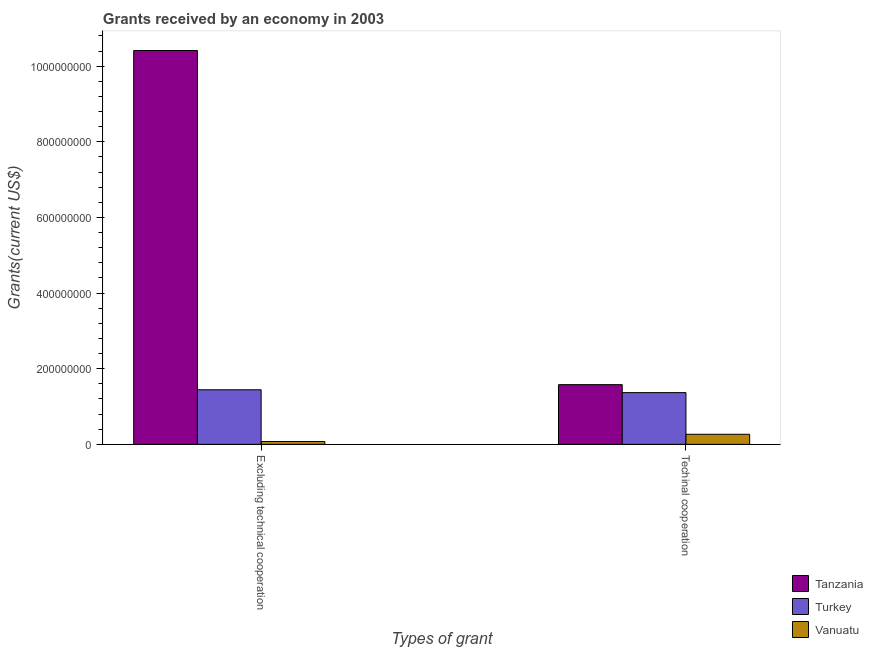Are the number of bars on each tick of the X-axis equal?
Make the answer very short. Yes. How many bars are there on the 2nd tick from the left?
Offer a terse response. 3. How many bars are there on the 1st tick from the right?
Your answer should be very brief. 3. What is the label of the 2nd group of bars from the left?
Offer a very short reply. Techinal cooperation. What is the amount of grants received(including technical cooperation) in Turkey?
Make the answer very short. 1.37e+08. Across all countries, what is the maximum amount of grants received(including technical cooperation)?
Your answer should be very brief. 1.58e+08. Across all countries, what is the minimum amount of grants received(excluding technical cooperation)?
Your response must be concise. 7.47e+06. In which country was the amount of grants received(excluding technical cooperation) maximum?
Your answer should be very brief. Tanzania. In which country was the amount of grants received(excluding technical cooperation) minimum?
Offer a terse response. Vanuatu. What is the total amount of grants received(including technical cooperation) in the graph?
Give a very brief answer. 3.21e+08. What is the difference between the amount of grants received(including technical cooperation) in Tanzania and that in Vanuatu?
Keep it short and to the point. 1.31e+08. What is the difference between the amount of grants received(excluding technical cooperation) in Turkey and the amount of grants received(including technical cooperation) in Vanuatu?
Your answer should be compact. 1.18e+08. What is the average amount of grants received(excluding technical cooperation) per country?
Your answer should be compact. 3.98e+08. What is the difference between the amount of grants received(including technical cooperation) and amount of grants received(excluding technical cooperation) in Turkey?
Your answer should be very brief. -7.53e+06. What is the ratio of the amount of grants received(excluding technical cooperation) in Vanuatu to that in Tanzania?
Ensure brevity in your answer.  0.01. Is the amount of grants received(excluding technical cooperation) in Vanuatu less than that in Turkey?
Keep it short and to the point. Yes. What does the 2nd bar from the left in Techinal cooperation represents?
Ensure brevity in your answer.  Turkey. What does the 1st bar from the right in Excluding technical cooperation represents?
Provide a succinct answer. Vanuatu. Are all the bars in the graph horizontal?
Your response must be concise. No. Does the graph contain grids?
Give a very brief answer. No. Where does the legend appear in the graph?
Offer a terse response. Bottom right. How many legend labels are there?
Make the answer very short. 3. How are the legend labels stacked?
Keep it short and to the point. Vertical. What is the title of the graph?
Your response must be concise. Grants received by an economy in 2003. Does "Qatar" appear as one of the legend labels in the graph?
Ensure brevity in your answer.  No. What is the label or title of the X-axis?
Give a very brief answer. Types of grant. What is the label or title of the Y-axis?
Provide a short and direct response. Grants(current US$). What is the Grants(current US$) of Tanzania in Excluding technical cooperation?
Give a very brief answer. 1.04e+09. What is the Grants(current US$) in Turkey in Excluding technical cooperation?
Make the answer very short. 1.44e+08. What is the Grants(current US$) in Vanuatu in Excluding technical cooperation?
Your answer should be very brief. 7.47e+06. What is the Grants(current US$) of Tanzania in Techinal cooperation?
Your answer should be very brief. 1.58e+08. What is the Grants(current US$) of Turkey in Techinal cooperation?
Offer a terse response. 1.37e+08. What is the Grants(current US$) of Vanuatu in Techinal cooperation?
Provide a succinct answer. 2.67e+07. Across all Types of grant, what is the maximum Grants(current US$) of Tanzania?
Offer a terse response. 1.04e+09. Across all Types of grant, what is the maximum Grants(current US$) in Turkey?
Make the answer very short. 1.44e+08. Across all Types of grant, what is the maximum Grants(current US$) in Vanuatu?
Provide a short and direct response. 2.67e+07. Across all Types of grant, what is the minimum Grants(current US$) in Tanzania?
Provide a succinct answer. 1.58e+08. Across all Types of grant, what is the minimum Grants(current US$) in Turkey?
Your response must be concise. 1.37e+08. Across all Types of grant, what is the minimum Grants(current US$) in Vanuatu?
Provide a succinct answer. 7.47e+06. What is the total Grants(current US$) in Tanzania in the graph?
Your response must be concise. 1.20e+09. What is the total Grants(current US$) in Turkey in the graph?
Offer a terse response. 2.81e+08. What is the total Grants(current US$) of Vanuatu in the graph?
Your response must be concise. 3.41e+07. What is the difference between the Grants(current US$) of Tanzania in Excluding technical cooperation and that in Techinal cooperation?
Provide a short and direct response. 8.84e+08. What is the difference between the Grants(current US$) of Turkey in Excluding technical cooperation and that in Techinal cooperation?
Your answer should be compact. 7.53e+06. What is the difference between the Grants(current US$) of Vanuatu in Excluding technical cooperation and that in Techinal cooperation?
Your answer should be very brief. -1.92e+07. What is the difference between the Grants(current US$) of Tanzania in Excluding technical cooperation and the Grants(current US$) of Turkey in Techinal cooperation?
Ensure brevity in your answer.  9.05e+08. What is the difference between the Grants(current US$) in Tanzania in Excluding technical cooperation and the Grants(current US$) in Vanuatu in Techinal cooperation?
Your answer should be compact. 1.01e+09. What is the difference between the Grants(current US$) in Turkey in Excluding technical cooperation and the Grants(current US$) in Vanuatu in Techinal cooperation?
Your answer should be very brief. 1.18e+08. What is the average Grants(current US$) of Tanzania per Types of grant?
Give a very brief answer. 6.00e+08. What is the average Grants(current US$) in Turkey per Types of grant?
Keep it short and to the point. 1.41e+08. What is the average Grants(current US$) of Vanuatu per Types of grant?
Your response must be concise. 1.71e+07. What is the difference between the Grants(current US$) of Tanzania and Grants(current US$) of Turkey in Excluding technical cooperation?
Ensure brevity in your answer.  8.97e+08. What is the difference between the Grants(current US$) in Tanzania and Grants(current US$) in Vanuatu in Excluding technical cooperation?
Your answer should be compact. 1.03e+09. What is the difference between the Grants(current US$) of Turkey and Grants(current US$) of Vanuatu in Excluding technical cooperation?
Offer a terse response. 1.37e+08. What is the difference between the Grants(current US$) of Tanzania and Grants(current US$) of Turkey in Techinal cooperation?
Keep it short and to the point. 2.11e+07. What is the difference between the Grants(current US$) of Tanzania and Grants(current US$) of Vanuatu in Techinal cooperation?
Ensure brevity in your answer.  1.31e+08. What is the difference between the Grants(current US$) in Turkey and Grants(current US$) in Vanuatu in Techinal cooperation?
Offer a terse response. 1.10e+08. What is the ratio of the Grants(current US$) of Tanzania in Excluding technical cooperation to that in Techinal cooperation?
Your answer should be very brief. 6.6. What is the ratio of the Grants(current US$) of Turkey in Excluding technical cooperation to that in Techinal cooperation?
Your response must be concise. 1.05. What is the ratio of the Grants(current US$) of Vanuatu in Excluding technical cooperation to that in Techinal cooperation?
Provide a succinct answer. 0.28. What is the difference between the highest and the second highest Grants(current US$) of Tanzania?
Your answer should be very brief. 8.84e+08. What is the difference between the highest and the second highest Grants(current US$) in Turkey?
Offer a terse response. 7.53e+06. What is the difference between the highest and the second highest Grants(current US$) of Vanuatu?
Provide a succinct answer. 1.92e+07. What is the difference between the highest and the lowest Grants(current US$) in Tanzania?
Your answer should be compact. 8.84e+08. What is the difference between the highest and the lowest Grants(current US$) of Turkey?
Offer a terse response. 7.53e+06. What is the difference between the highest and the lowest Grants(current US$) in Vanuatu?
Ensure brevity in your answer.  1.92e+07. 